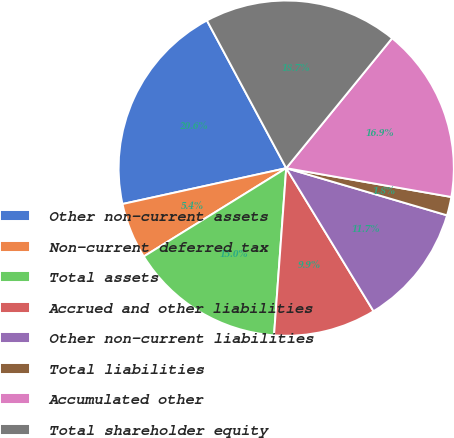Convert chart to OTSL. <chart><loc_0><loc_0><loc_500><loc_500><pie_chart><fcel>Other non-current assets<fcel>Non-current deferred tax<fcel>Total assets<fcel>Accrued and other liabilities<fcel>Other non-current liabilities<fcel>Total liabilities<fcel>Accumulated other<fcel>Total shareholder equity<nl><fcel>20.59%<fcel>5.4%<fcel>15.01%<fcel>9.88%<fcel>11.74%<fcel>1.79%<fcel>16.87%<fcel>18.73%<nl></chart> 